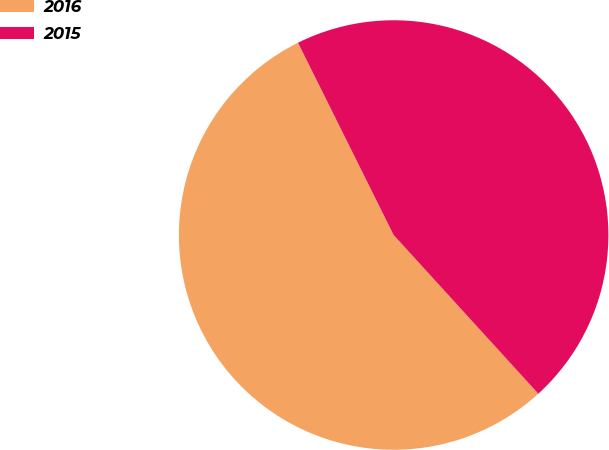Convert chart. <chart><loc_0><loc_0><loc_500><loc_500><pie_chart><fcel>2016<fcel>2015<nl><fcel>54.42%<fcel>45.58%<nl></chart> 